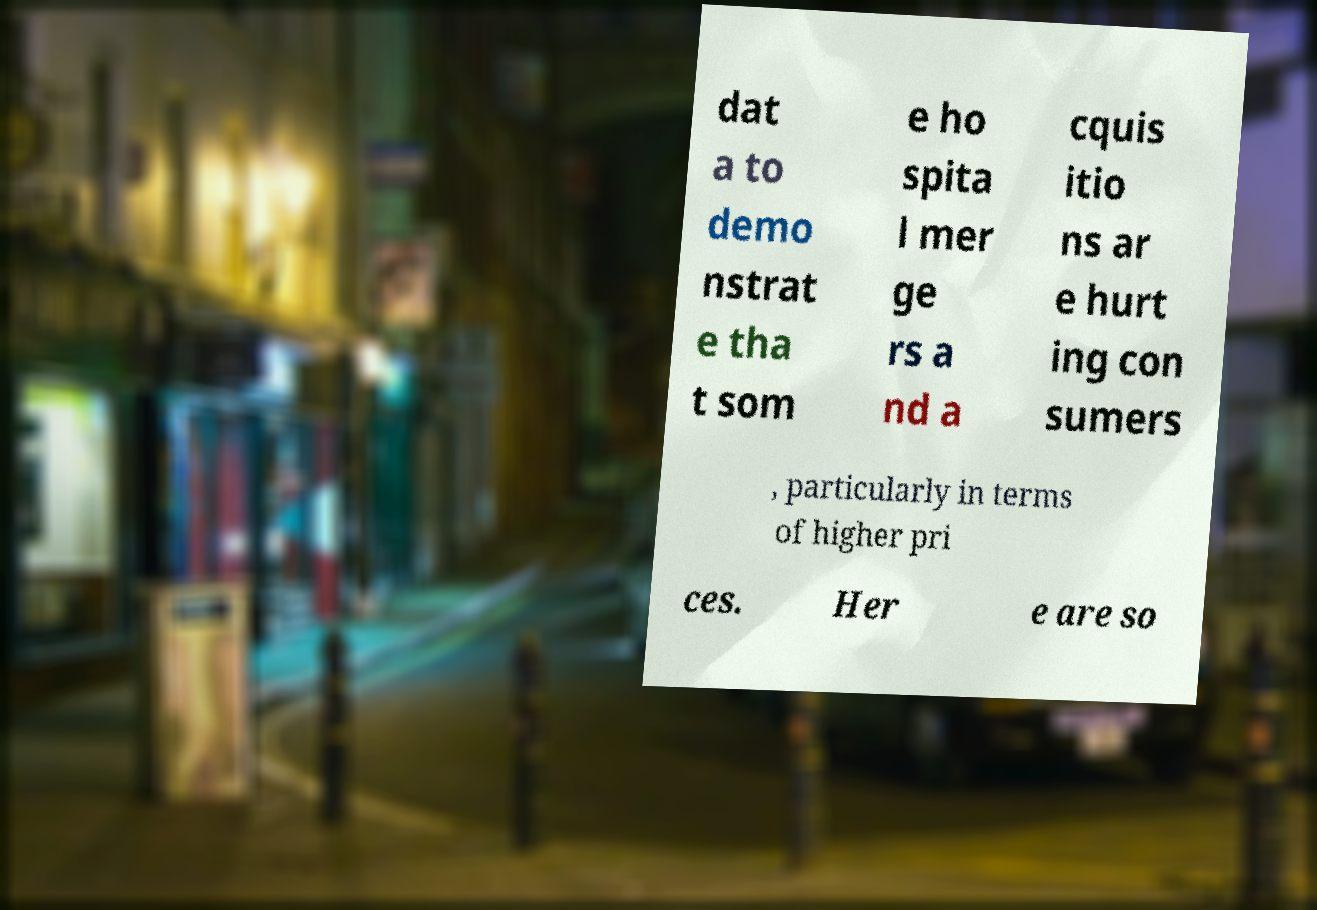What messages or text are displayed in this image? I need them in a readable, typed format. dat a to demo nstrat e tha t som e ho spita l mer ge rs a nd a cquis itio ns ar e hurt ing con sumers , particularly in terms of higher pri ces. Her e are so 